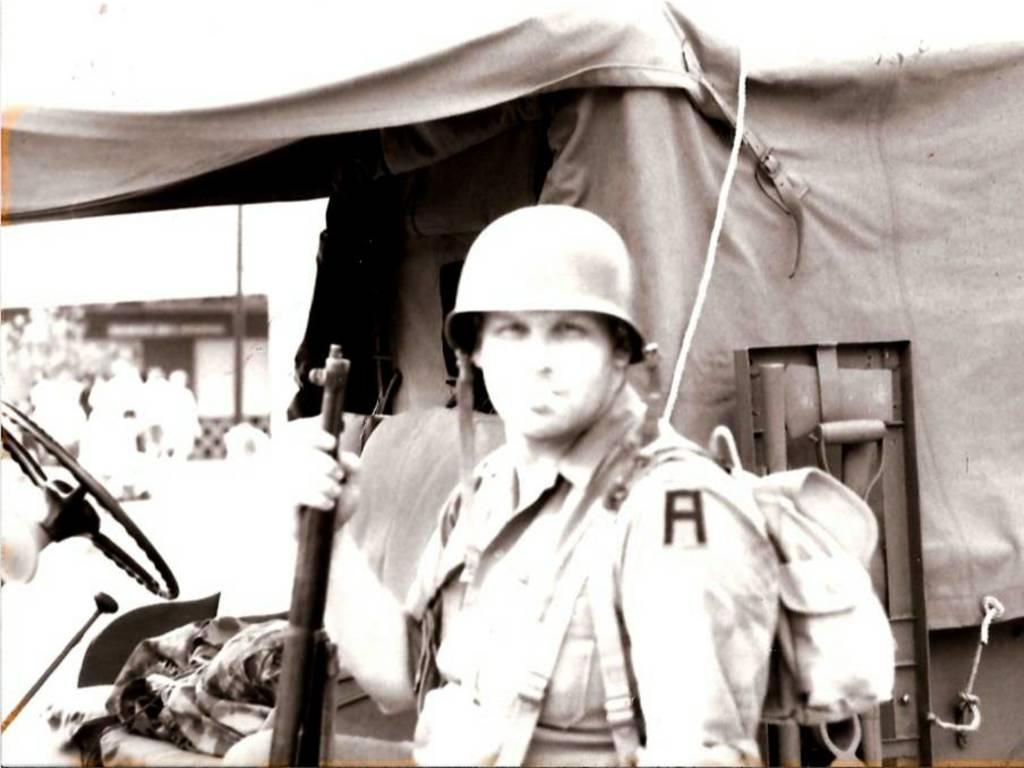Can you describe this image briefly? In the picture I can see a man in the middle of the image and he is holding a weapon in his right hand. There is a helmet on his head and he is carrying a bag on his back. In the background, I can see a vehicle. 